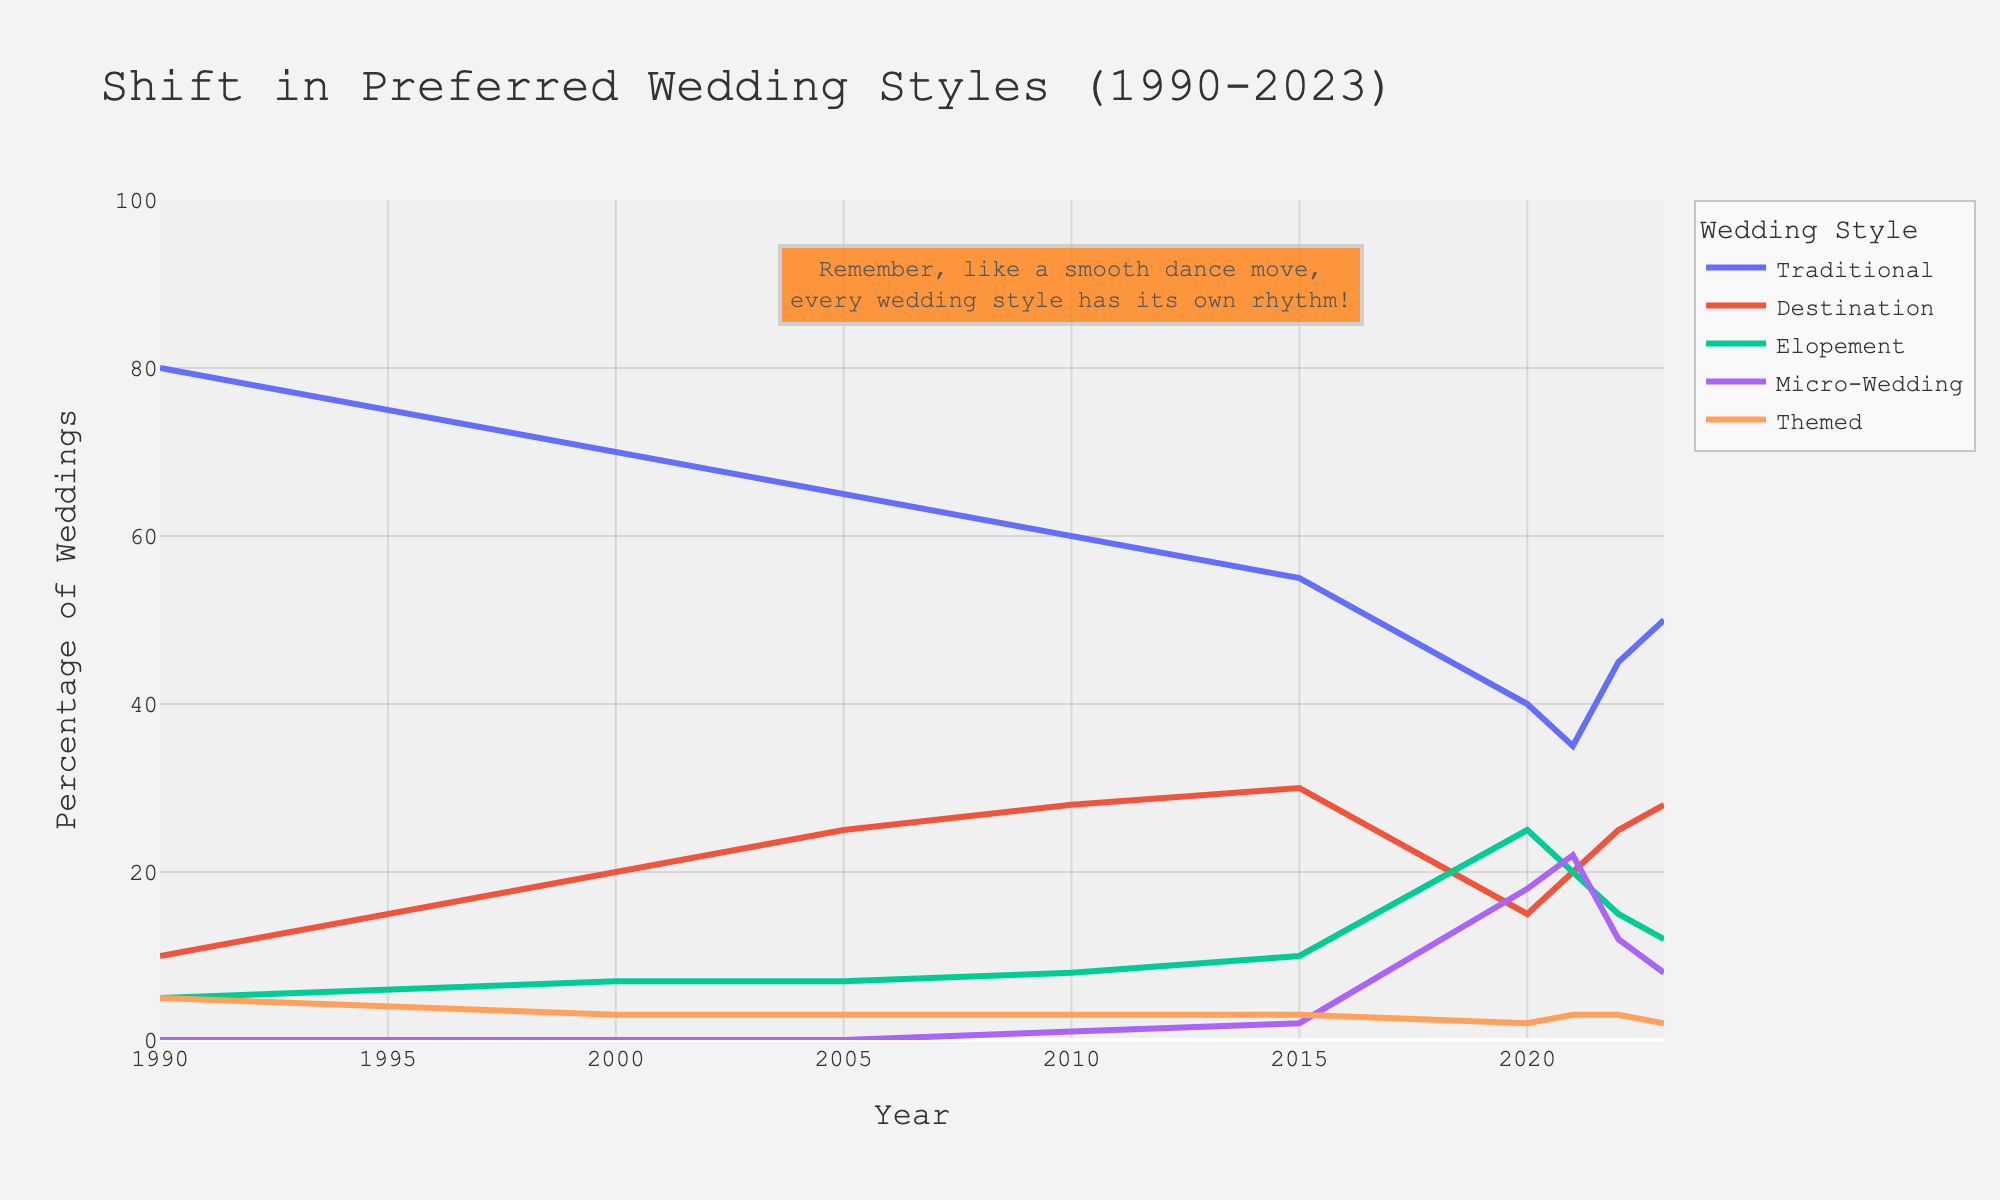What is the general trend for traditional weddings from 1990 to 2023? From the figure, traditional weddings show a decreasing trend. In 1990, traditional weddings were at 80%, and by 2023, they dropped to 50%.
Answer: Decreasing Which wedding style had the lowest percentage in 2023? Looking at the figure, the lines representing the percentages show that Themed weddings had the lowest percentage in 2023.
Answer: Themed In which year did destination weddings reach their peak? From the line representing destination weddings, it reached its peak in 2015 with 30%.
Answer: 2015 Compare the percentage of elopement weddings in 2000 and 2020. Which year had a higher percentage, and by how much? In 2000, elopement weddings were at 7%, and in 2020, they were at 25%. The difference is 25% - 7% = 18%.
Answer: 2020 by 18% What is the sum of the percentages of micro-weddings and themed weddings in 2021? In 2021, micro-weddings were at 22% and themed weddings were at 3%. The sum is 22% + 3% = 25%.
Answer: 25% By how many percentage points did the traditional wedding style drop from 1990 to 2020? The percentage of traditional weddings in 1990 was 80%, and in 2020, it was 40%. The drop is 80% - 40% = 40 percentage points.
Answer: 40 percentage points Which wedding style showed the most significant increase from 2010 to 2020? By visually comparing the slopes of the lines for each wedding style, elopement weddings had the most significant increase, going from 8% in 2010 to 25% in 2020, which is an increase of 17 percentage points.
Answer: Elopement Do any of the wedding styles show a dip in percentage from 2021 to 2023? If so, which ones? Observing the figure, micro-weddings show a dip, going from 22% in 2021 to 8% in 2023. Elopement weddings also show a dip, going from 20% in 2021 to 12% in 2023.
Answer: Micro-weddings and Elopement Which year had the least percentage for traditional weddings and what was it? The least percentage for traditional weddings is seen in 2021 with 35%.
Answer: 2021 at 35% What is the average percentage of themed weddings over the period from 1990 to 2023? The percentages for themed weddings from 1990 to 2023 are: 5, 4, 3, 3, 3, 3, 2, 3, 3, and 2. Summing these gives 31. The total number of years is 10. Therefore, the average is 31/10 = 3.1.
Answer: 3.1 